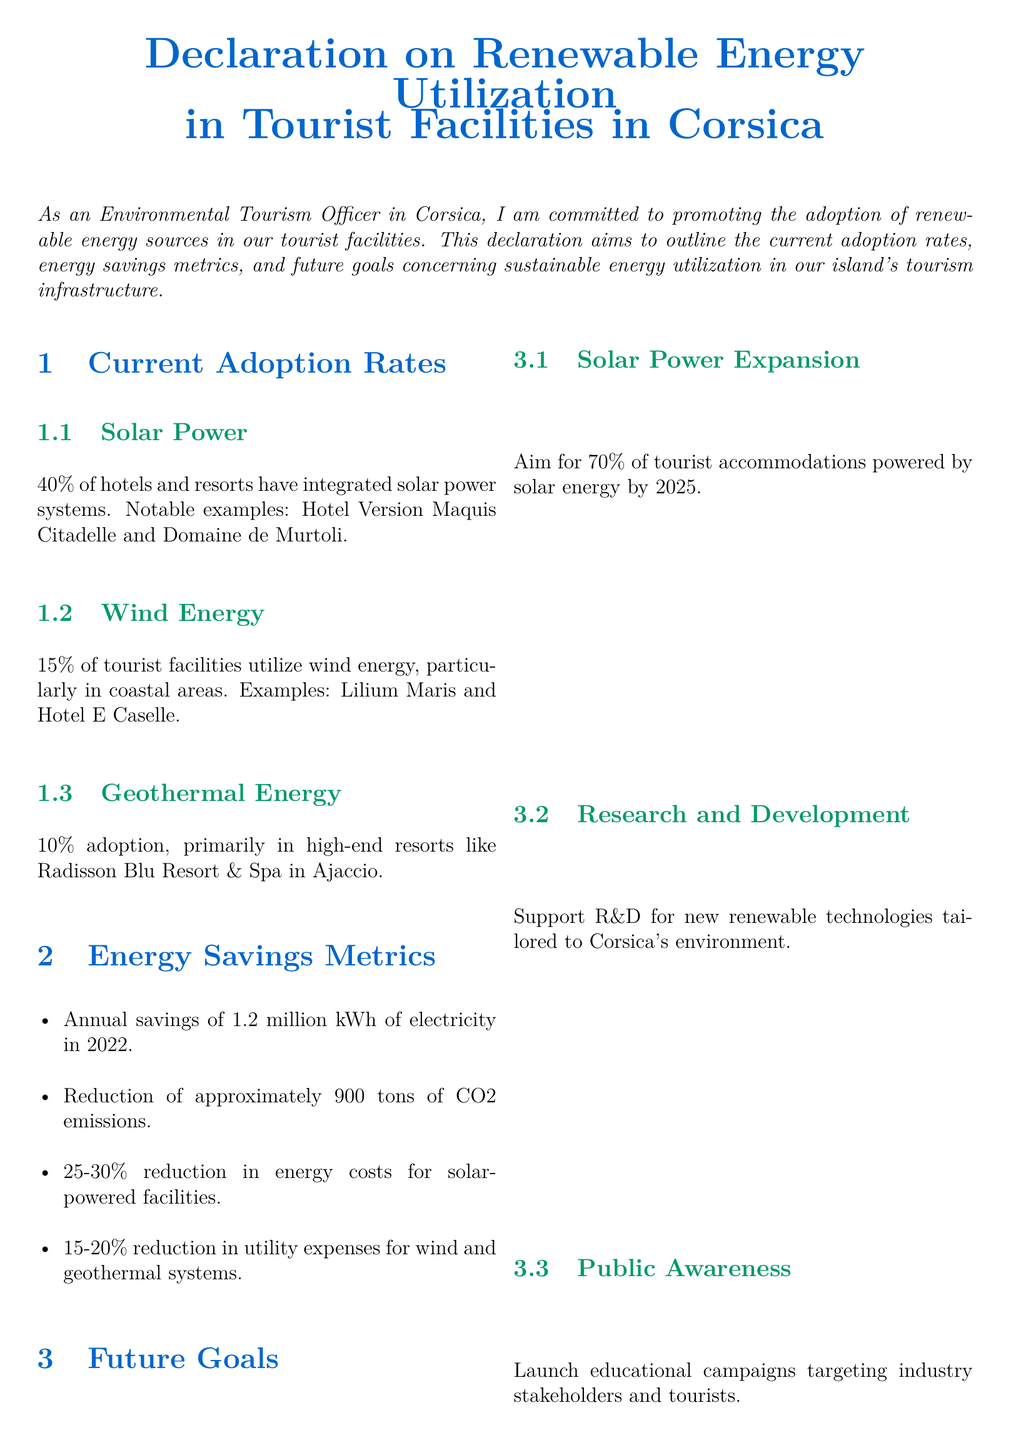What percentage of hotels and resorts have solar power systems? The document states that 40% of hotels and resorts have integrated solar power systems.
Answer: 40% Which tourist facility is an example of wind energy utilization? It mentions Lilium Maris as an example of a facility utilizing wind energy.
Answer: Lilium Maris What is the annual electricity savings reported for 2022? The document states that there were annual savings of 1.2 million kWh of electricity in 2022.
Answer: 1.2 million kWh What percentage adoption rate is reported for geothermal energy? The document indicates a 10% adoption rate for geothermal energy among tourist facilities.
Answer: 10% What is the future goal for solar power expansion by 2025? It aims for 70% of tourist accommodations powered by solar energy by 2025.
Answer: 70% How much was the reduction in CO2 emissions? The document states a reduction of approximately 900 tons of CO2 emissions.
Answer: 900 tons What is one of the future goals regarding public awareness? The future goal includes launching educational campaigns targeting industry stakeholders and tourists.
Answer: Educational campaigns Which resort is specialized in geothermal energy? It mentions Radisson Blu Resort & Spa in Ajaccio as a facility that adopts geothermal energy.
Answer: Radisson Blu Resort & Spa in Ajaccio 